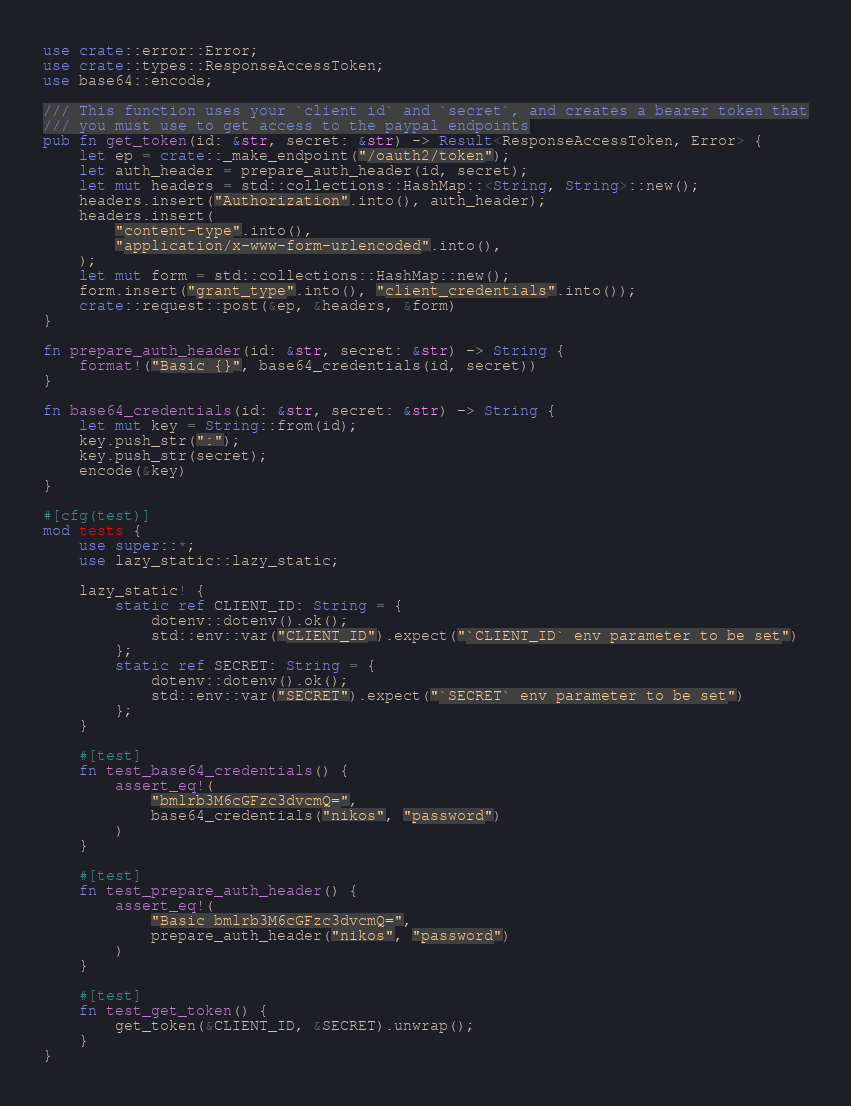Convert code to text. <code><loc_0><loc_0><loc_500><loc_500><_Rust_>use crate::error::Error;
use crate::types::ResponseAccessToken;
use base64::encode;

/// This function uses your `client id` and `secret`, and creates a bearer token that
/// you must use to get access to the paypal endpoints
pub fn get_token(id: &str, secret: &str) -> Result<ResponseAccessToken, Error> {
    let ep = crate::_make_endpoint("/oauth2/token");
    let auth_header = prepare_auth_header(id, secret);
    let mut headers = std::collections::HashMap::<String, String>::new();
    headers.insert("Authorization".into(), auth_header);
    headers.insert(
        "content-type".into(),
        "application/x-www-form-urlencoded".into(),
    );
    let mut form = std::collections::HashMap::new();
    form.insert("grant_type".into(), "client_credentials".into());
    crate::request::post(&ep, &headers, &form)
}

fn prepare_auth_header(id: &str, secret: &str) -> String {
    format!("Basic {}", base64_credentials(id, secret))
}

fn base64_credentials(id: &str, secret: &str) -> String {
    let mut key = String::from(id);
    key.push_str(":");
    key.push_str(secret);
    encode(&key)
}

#[cfg(test)]
mod tests {
    use super::*;
    use lazy_static::lazy_static;

    lazy_static! {
        static ref CLIENT_ID: String = {
            dotenv::dotenv().ok();
            std::env::var("CLIENT_ID").expect("`CLIENT_ID` env parameter to be set")
        };
        static ref SECRET: String = {
            dotenv::dotenv().ok();
            std::env::var("SECRET").expect("`SECRET` env parameter to be set")
        };
    }

    #[test]
    fn test_base64_credentials() {
        assert_eq!(
            "bmlrb3M6cGFzc3dvcmQ=",
            base64_credentials("nikos", "password")
        )
    }

    #[test]
    fn test_prepare_auth_header() {
        assert_eq!(
            "Basic bmlrb3M6cGFzc3dvcmQ=",
            prepare_auth_header("nikos", "password")
        )
    }

    #[test]
    fn test_get_token() {
        get_token(&CLIENT_ID, &SECRET).unwrap();
    }
}
</code> 